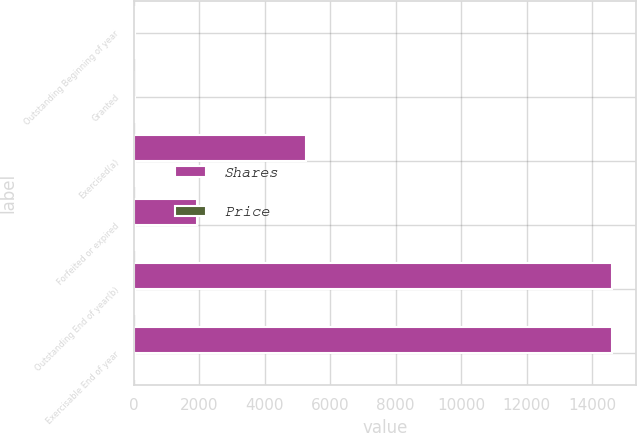Convert chart to OTSL. <chart><loc_0><loc_0><loc_500><loc_500><stacked_bar_chart><ecel><fcel>Outstanding Beginning of year<fcel>Granted<fcel>Exercised(a)<fcel>Forfeited or expired<fcel>Outstanding End of year(b)<fcel>Exercisable End of year<nl><fcel>Shares<fcel>38.47<fcel>17<fcel>5252<fcel>1924<fcel>14620<fcel>14618<nl><fcel>Price<fcel>29.52<fcel>38.47<fcel>25.96<fcel>40.75<fcel>29.33<fcel>29.33<nl></chart> 